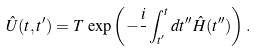Convert formula to latex. <formula><loc_0><loc_0><loc_500><loc_500>\hat { U } ( t , t ^ { \prime } ) = T \, \exp { \left ( - \frac { i } { } \int ^ { t } _ { t ^ { \prime } } d t ^ { \prime \prime } \hat { H } ( t ^ { \prime \prime } ) \right ) } \, .</formula> 